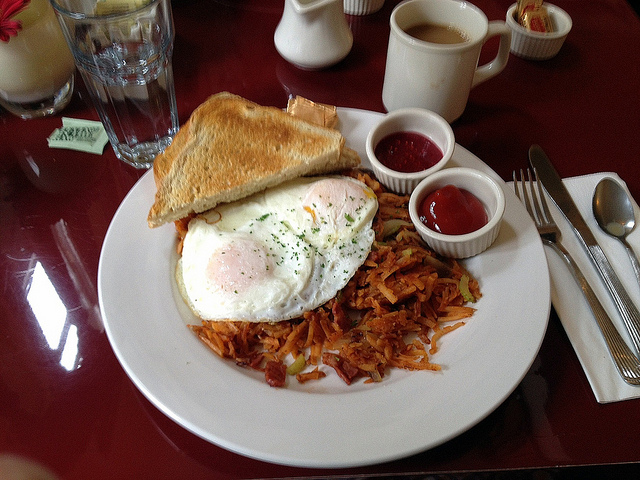What type of breakfast foods are on the white plate?
 The white plate is topped with various breakfast foods, including hash browns, eggs, and toast. There are also two containers of ketchup provided with the meal. What is the state of the meal? The meal is prepared and ready to eat. Are there any utensils visible in the image? Yes, there are utensils on the table next to the plate of food. What condiment is provided with the breakfast meal? Ketchup is the condiment provided with the breakfast meal. There are two containers of it on the plate. How do the various food items on the plate complement each other to make a balanced breakfast? The combination of hash browns, eggs, toast, and ketchup provides a balanced breakfast in terms of taste, texture, and nutritional content. Each food item brings something unique to the table, creating a satisfying meal. 

1. Hash browns: Made from grated or shredded potatoes that are fried until they attain a crispy texture, hash browns add a savory element to the plate. Their crispy exterior and soft interior creates a pleasing contrast. In terms of nutrition, potatoes are a source of complex carbohydrates and vitamins, providing energy for the day.

2. Eggs: Rich in protein, vitamins, and minerals, eggs are a versatile and nutritious breakfast choice. They can be prepared in several ways, such as scrambled, fried, or poached. The protein content in eggs helps keep you full and satisfied, while the vitamins and minerals support overall health.

3. Toast: Usually made from slices of bread that are toasted to create a crunchy texture, toast serves as a source of carbohydrates, fiber, and other nutrients. Topped with butter, jam, or other spreads, it adds variety and customization to the breakfast plate.

4. Ketchup: As a condiment, ketchup lends a tangy and mildly sweet flavor that complements the other breakfast items. It enhances the taste experience, bringing out the flavors of the hash browns, eggs, and toast while adding a touch of moisture and zesty flavor.

By combining these various food items, the breakfast plate offers a balanced and delicious meal that caters to different taste preferences and provides essential nutrients to help start the day on a positive note. 